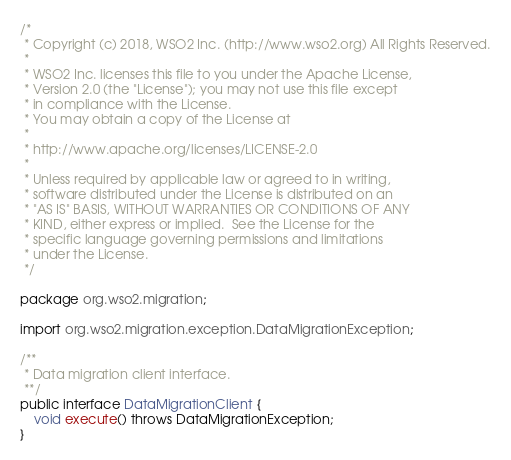<code> <loc_0><loc_0><loc_500><loc_500><_Java_>/*
 * Copyright (c) 2018, WSO2 Inc. (http://www.wso2.org) All Rights Reserved.
 *
 * WSO2 Inc. licenses this file to you under the Apache License,
 * Version 2.0 (the "License"); you may not use this file except
 * in compliance with the License.
 * You may obtain a copy of the License at
 *
 * http://www.apache.org/licenses/LICENSE-2.0
 *
 * Unless required by applicable law or agreed to in writing,
 * software distributed under the License is distributed on an
 * "AS IS" BASIS, WITHOUT WARRANTIES OR CONDITIONS OF ANY
 * KIND, either express or implied.  See the License for the
 * specific language governing permissions and limitations
 * under the License.
 */

package org.wso2.migration;

import org.wso2.migration.exception.DataMigrationException;

/**
 * Data migration client interface.
 **/
public interface DataMigrationClient {
    void execute() throws DataMigrationException;
}

</code> 